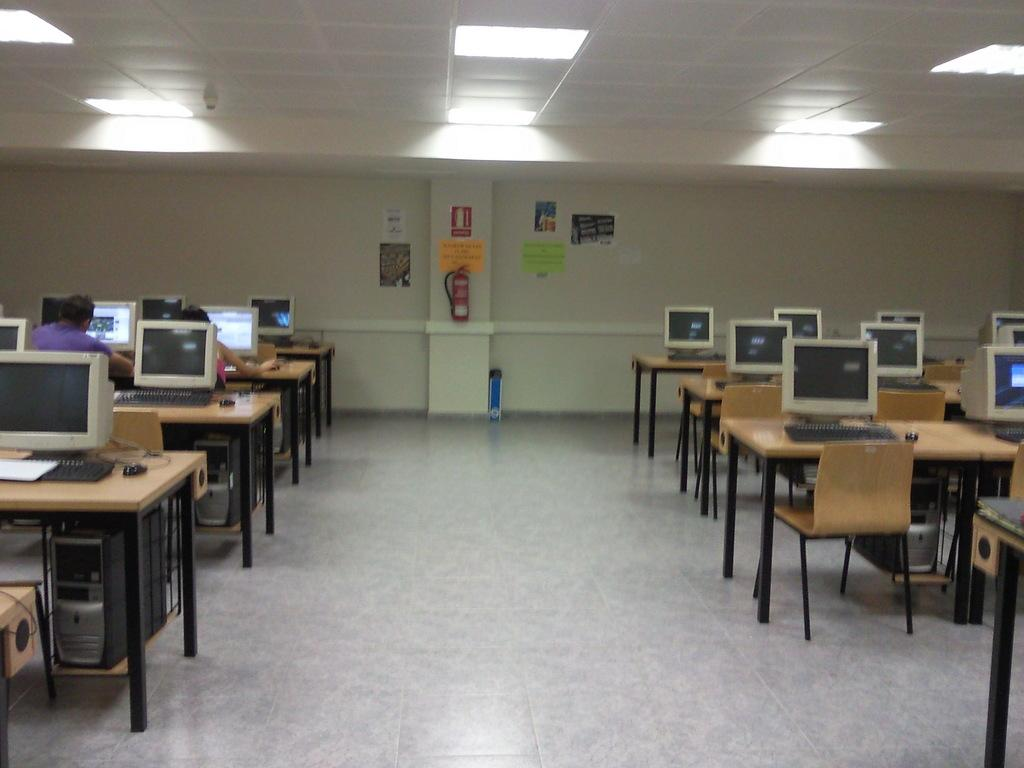What type of equipment can be seen on both sides of the image? Monitors, keyboards, CPUs, and mice are visible on both the right and left sides of the image. What type of furniture is present in the image? Tables are present on both the right and left sides of the image. What can be seen in the background of the image? There are persons, a wall, a fire extinguisher, and posters visible in the background of the image. Can you tell me how many friends are sitting on the ground in the image? There is no mention of friends or the ground in the image; it features computer equipment and a background with persons, a wall, a fire extinguisher, and posters. Who is the creator of the posters visible in the background of the image? The creator of the posters is not mentioned or identifiable in the image. 